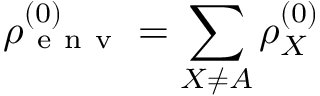Convert formula to latex. <formula><loc_0><loc_0><loc_500><loc_500>\rho _ { e n v } ^ { ( 0 ) } = \sum _ { X \ne A } \rho _ { X } ^ { ( 0 ) }</formula> 